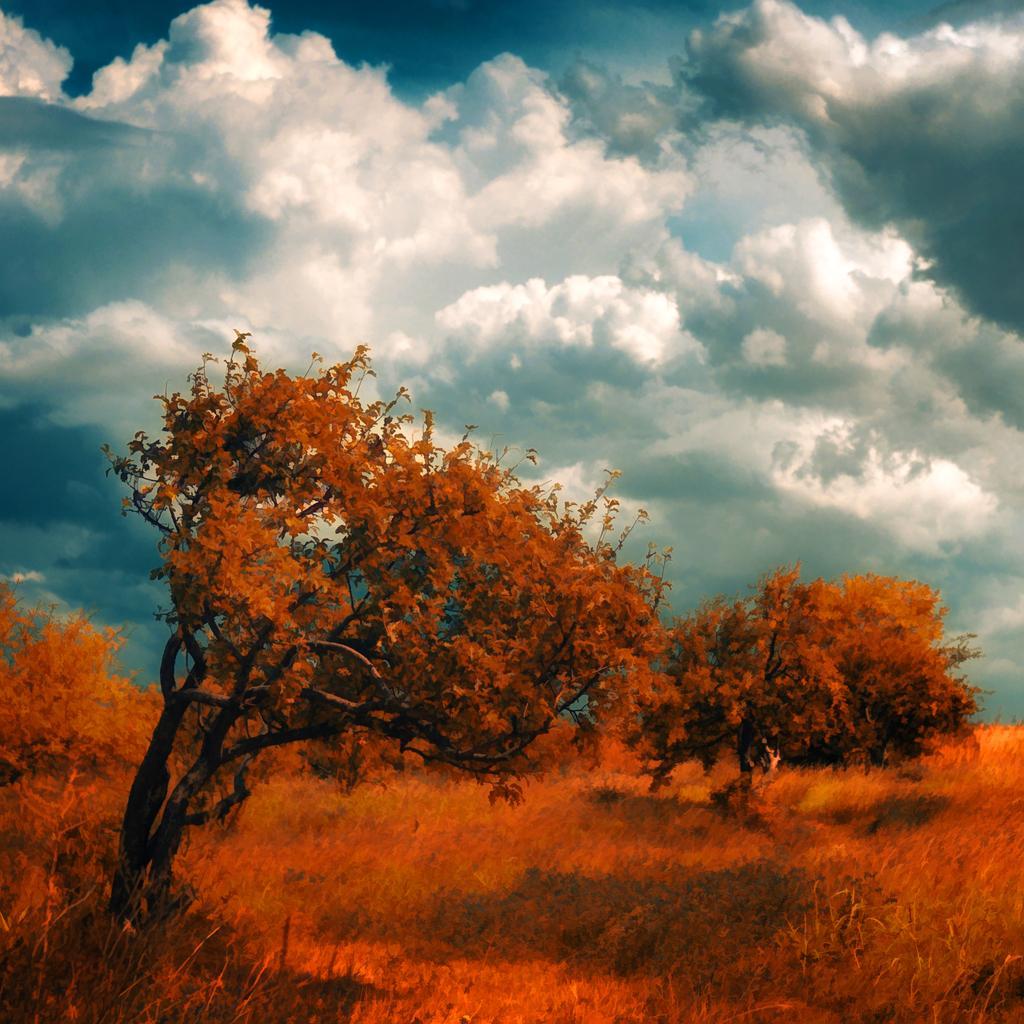How would you summarize this image in a sentence or two? In this pictures, there are trees and plants which are in orange in color are at the bottom. On the top there is a sky with clouds. 